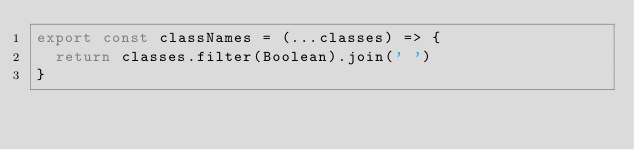Convert code to text. <code><loc_0><loc_0><loc_500><loc_500><_JavaScript_>export const classNames = (...classes) => {
  return classes.filter(Boolean).join(' ')
}</code> 